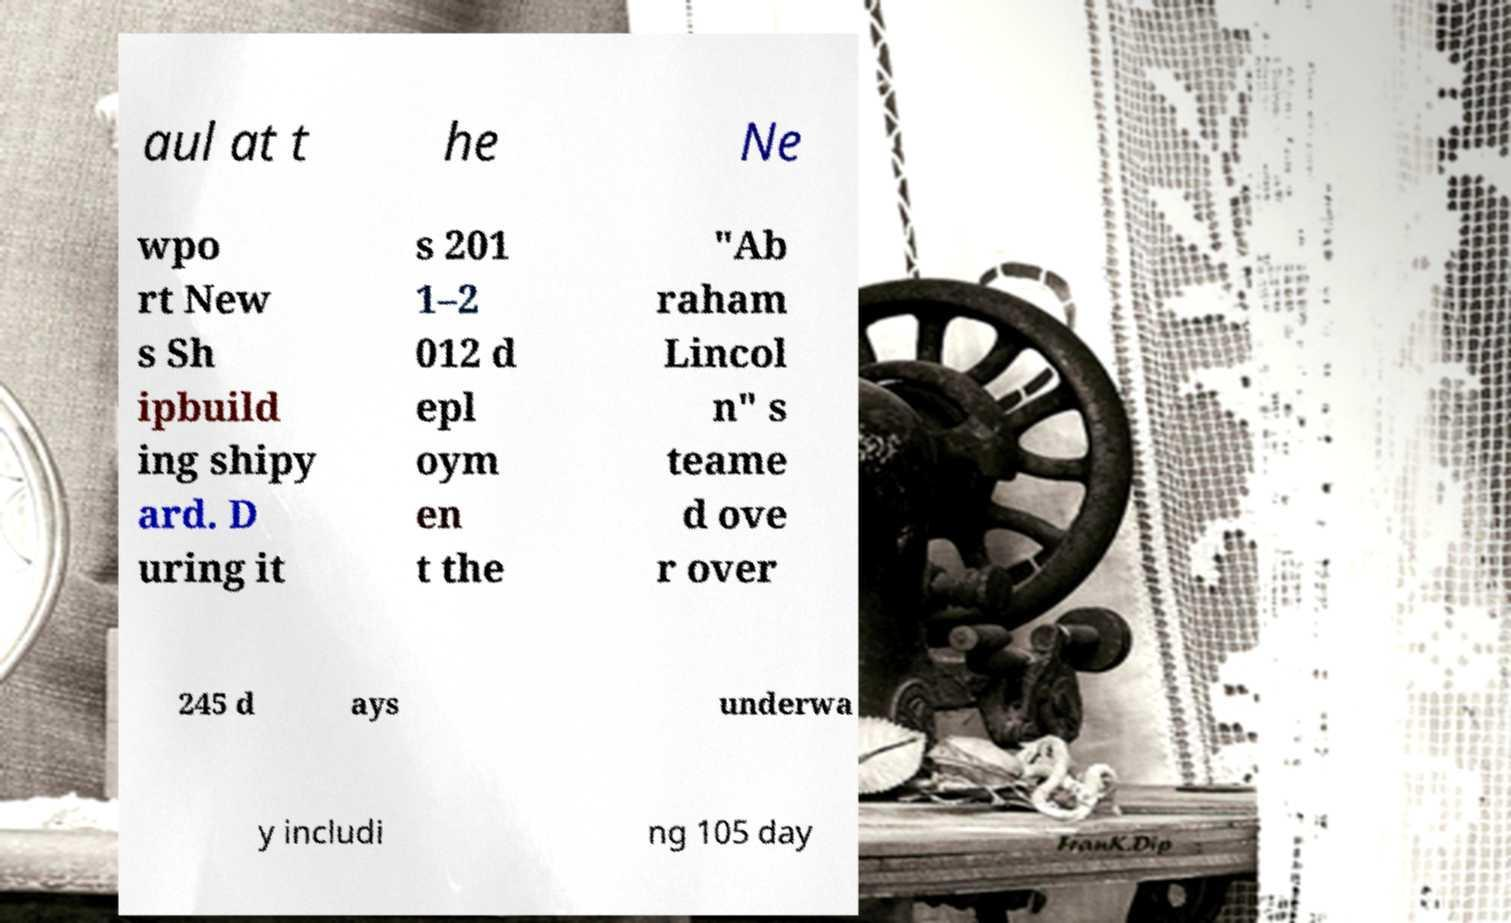I need the written content from this picture converted into text. Can you do that? aul at t he Ne wpo rt New s Sh ipbuild ing shipy ard. D uring it s 201 1–2 012 d epl oym en t the "Ab raham Lincol n" s teame d ove r over 245 d ays underwa y includi ng 105 day 